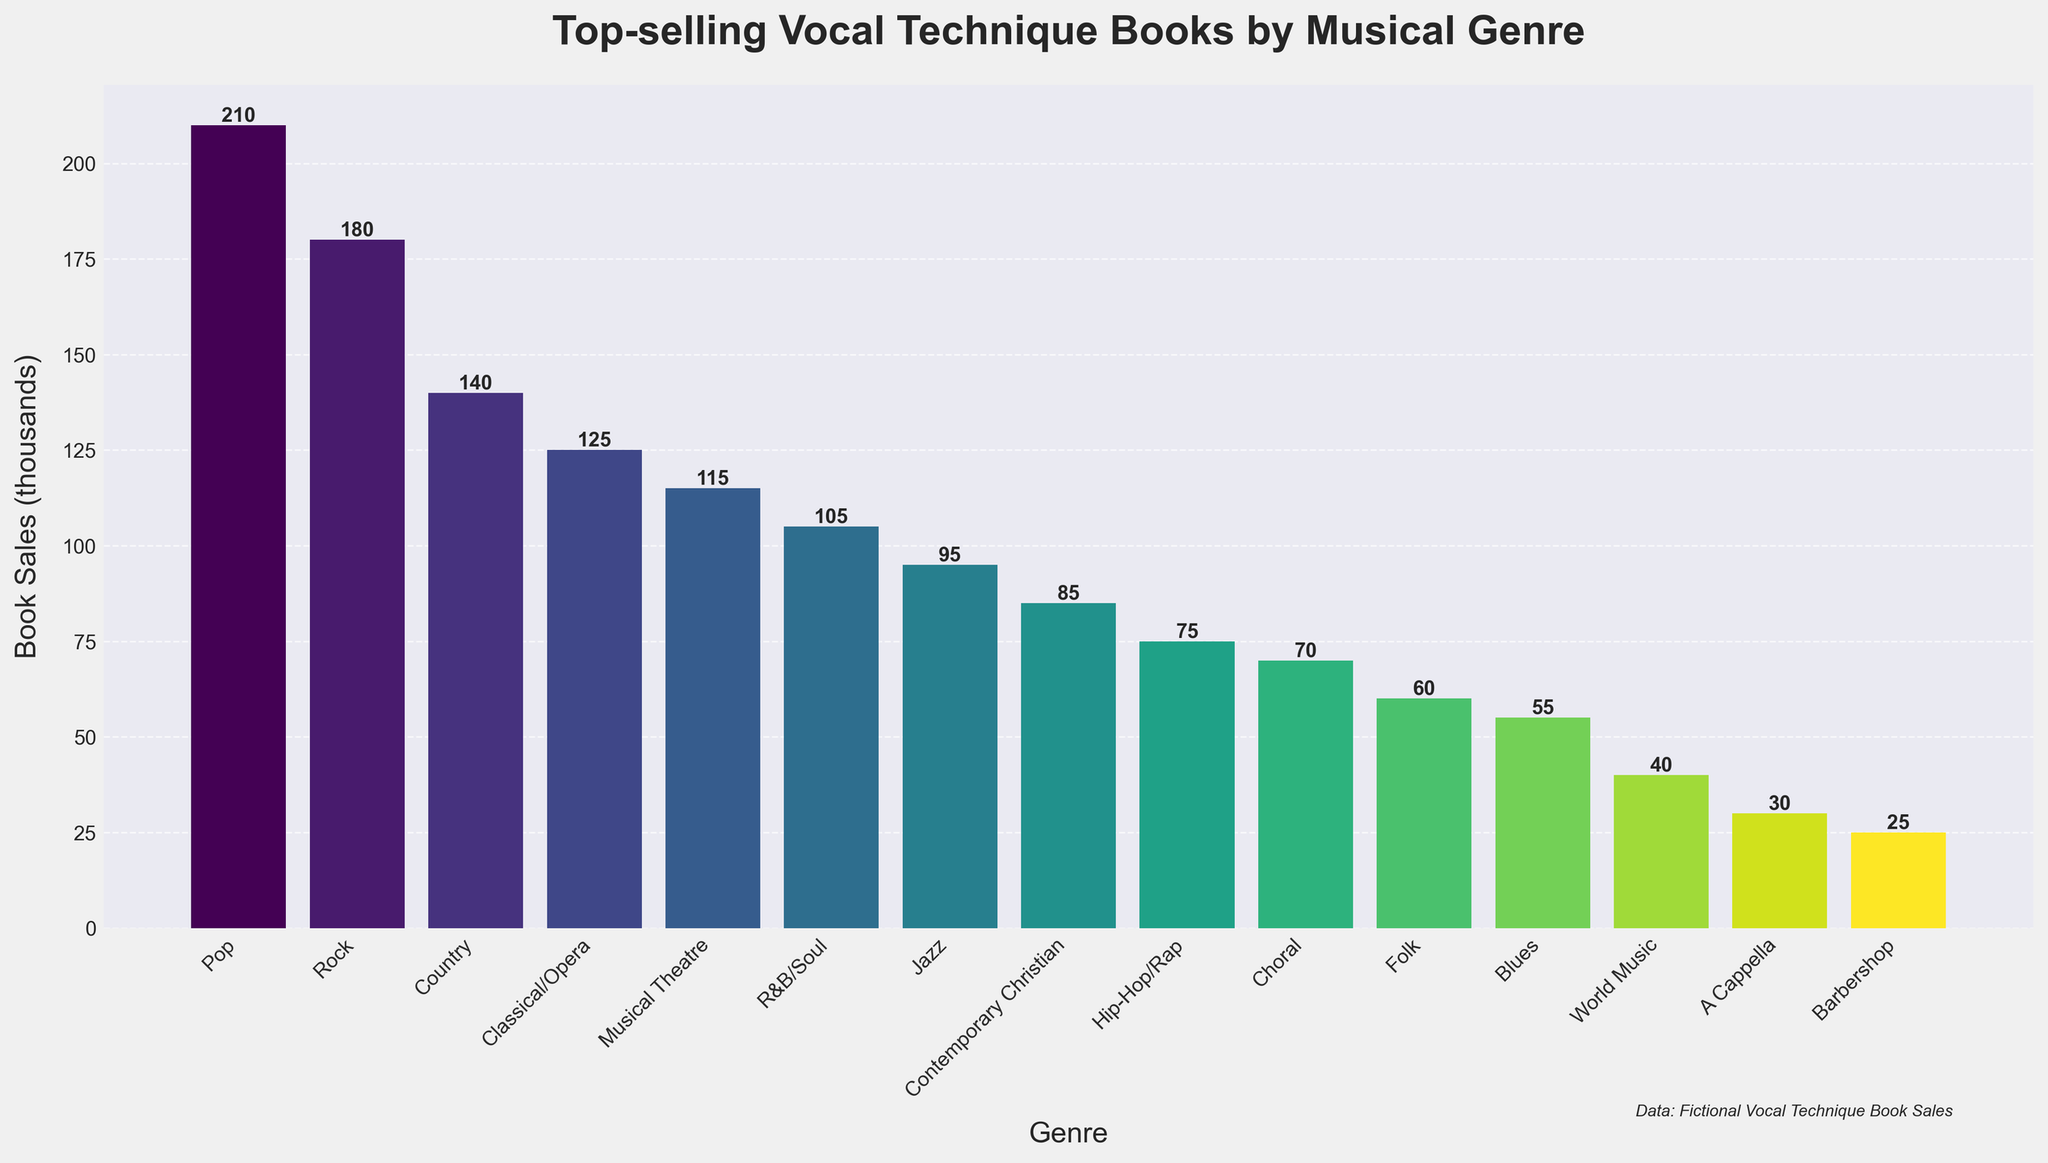Which genre has the highest book sales? The genre with the tallest bar represents the highest book sales. From the figure, Pop has the tallest bar.
Answer: Pop Which genre has the lowest book sales? The genre with the shortest bar represents the lowest book sales. Barbershop has the shortest bar.
Answer: Barbershop What is the combined sales for Folk, Blues, and World Music? Sum the book sales values for Folk (60), Blues (55), and World Music (40). The total is 60 + 55 + 40 = 155.
Answer: 155 Which genre has higher book sales: Jazz or R&B/Soul? Compare the heights of the bars for Jazz and R&B/Soul. R&B/Soul is higher than Jazz.
Answer: R&B/Soul How many genres have book sales exceeding 100,000 units? Count the number of bars with a height representing more than 100,000 units. There are Pop, Rock, Country, and Classical/Opera.
Answer: 4 Which genre has book sales closest to 100,000 units? Identify the bar that is nearest to the 100,000 mark. R&B/Soul at 105,000 is the closest.
Answer: R&B/Soul What is the total book sales for genres with fewer than 50,000 units? Sum the book sales values for genres with less than 50,000 units: World Music (40), A Cappella (30), and Barbershop (25). The total is 40 + 30 + 25 = 95.
Answer: 95 Is the book sales for Classical/Opera greater than the sum of Hip-Hop/Rap and Choral? Compare Classical/Opera's book sales (125) with the sum of Hip-Hop/Rap (75) and Choral (70). The sum is 75 + 70 = 145, which is greater than 125.
Answer: No What is the approximate range of the book sales data? The range is the difference between the highest and lowest book sales. Pop has the highest sales (210) and Barbershop has the lowest (25). So, the range is 210 - 25 = 185.
Answer: 185 Which two adjacent genres on the x-axis combined have the highest total book sales? Evaluate the sum of book sales for adjacent genres and compare them. Pop (210) and Rock (180) on the x-axis have the highest combined sales with a total of 210 + 180 = 390.
Answer: Pop and Rock 